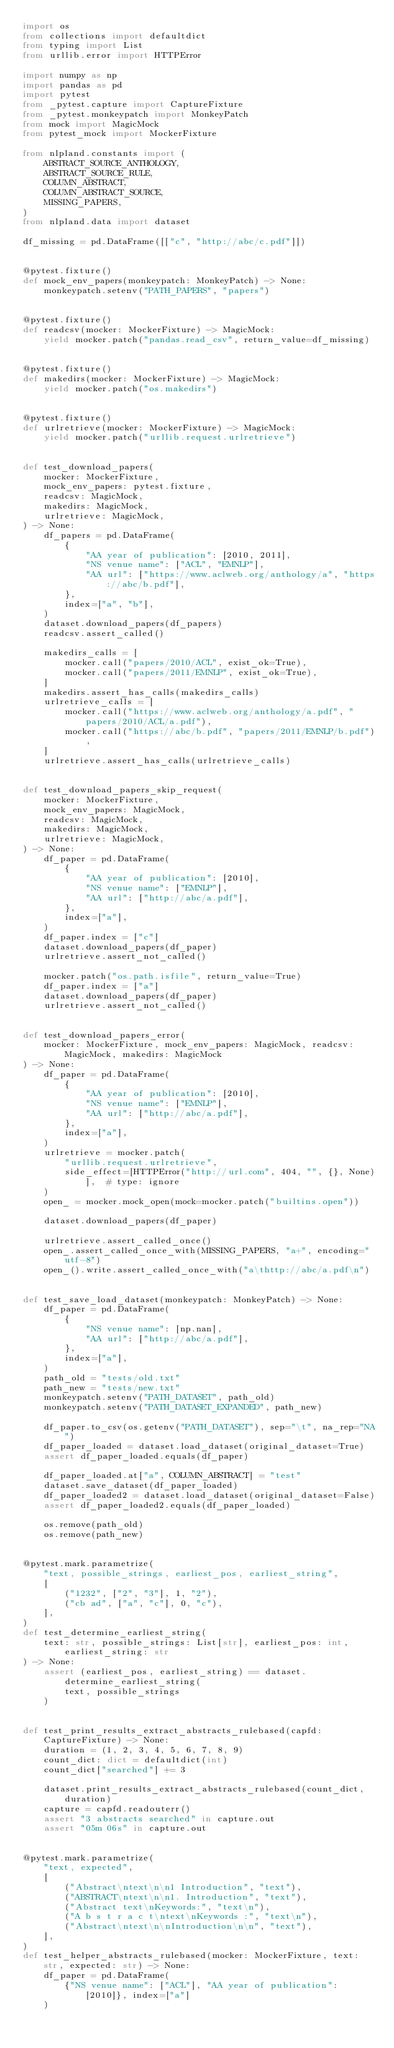Convert code to text. <code><loc_0><loc_0><loc_500><loc_500><_Python_>import os
from collections import defaultdict
from typing import List
from urllib.error import HTTPError

import numpy as np
import pandas as pd
import pytest
from _pytest.capture import CaptureFixture
from _pytest.monkeypatch import MonkeyPatch
from mock import MagicMock
from pytest_mock import MockerFixture

from nlpland.constants import (
    ABSTRACT_SOURCE_ANTHOLOGY,
    ABSTRACT_SOURCE_RULE,
    COLUMN_ABSTRACT,
    COLUMN_ABSTRACT_SOURCE,
    MISSING_PAPERS,
)
from nlpland.data import dataset

df_missing = pd.DataFrame([["c", "http://abc/c.pdf"]])


@pytest.fixture()
def mock_env_papers(monkeypatch: MonkeyPatch) -> None:
    monkeypatch.setenv("PATH_PAPERS", "papers")


@pytest.fixture()
def readcsv(mocker: MockerFixture) -> MagicMock:
    yield mocker.patch("pandas.read_csv", return_value=df_missing)


@pytest.fixture()
def makedirs(mocker: MockerFixture) -> MagicMock:
    yield mocker.patch("os.makedirs")


@pytest.fixture()
def urlretrieve(mocker: MockerFixture) -> MagicMock:
    yield mocker.patch("urllib.request.urlretrieve")


def test_download_papers(
    mocker: MockerFixture,
    mock_env_papers: pytest.fixture,
    readcsv: MagicMock,
    makedirs: MagicMock,
    urlretrieve: MagicMock,
) -> None:
    df_papers = pd.DataFrame(
        {
            "AA year of publication": [2010, 2011],
            "NS venue name": ["ACL", "EMNLP"],
            "AA url": ["https://www.aclweb.org/anthology/a", "https://abc/b.pdf"],
        },
        index=["a", "b"],
    )
    dataset.download_papers(df_papers)
    readcsv.assert_called()

    makedirs_calls = [
        mocker.call("papers/2010/ACL", exist_ok=True),
        mocker.call("papers/2011/EMNLP", exist_ok=True),
    ]
    makedirs.assert_has_calls(makedirs_calls)
    urlretrieve_calls = [
        mocker.call("https://www.aclweb.org/anthology/a.pdf", "papers/2010/ACL/a.pdf"),
        mocker.call("https://abc/b.pdf", "papers/2011/EMNLP/b.pdf"),
    ]
    urlretrieve.assert_has_calls(urlretrieve_calls)


def test_download_papers_skip_request(
    mocker: MockerFixture,
    mock_env_papers: MagicMock,
    readcsv: MagicMock,
    makedirs: MagicMock,
    urlretrieve: MagicMock,
) -> None:
    df_paper = pd.DataFrame(
        {
            "AA year of publication": [2010],
            "NS venue name": ["EMNLP"],
            "AA url": ["http://abc/a.pdf"],
        },
        index=["a"],
    )
    df_paper.index = ["c"]
    dataset.download_papers(df_paper)
    urlretrieve.assert_not_called()

    mocker.patch("os.path.isfile", return_value=True)
    df_paper.index = ["a"]
    dataset.download_papers(df_paper)
    urlretrieve.assert_not_called()


def test_download_papers_error(
    mocker: MockerFixture, mock_env_papers: MagicMock, readcsv: MagicMock, makedirs: MagicMock
) -> None:
    df_paper = pd.DataFrame(
        {
            "AA year of publication": [2010],
            "NS venue name": ["EMNLP"],
            "AA url": ["http://abc/a.pdf"],
        },
        index=["a"],
    )
    urlretrieve = mocker.patch(
        "urllib.request.urlretrieve",
        side_effect=[HTTPError("http://url.com", 404, "", {}, None)],  # type: ignore
    )
    open_ = mocker.mock_open(mock=mocker.patch("builtins.open"))

    dataset.download_papers(df_paper)

    urlretrieve.assert_called_once()
    open_.assert_called_once_with(MISSING_PAPERS, "a+", encoding="utf-8")
    open_().write.assert_called_once_with("a\thttp://abc/a.pdf\n")


def test_save_load_dataset(monkeypatch: MonkeyPatch) -> None:
    df_paper = pd.DataFrame(
        {
            "NS venue name": [np.nan],
            "AA url": ["http://abc/a.pdf"],
        },
        index=["a"],
    )
    path_old = "tests/old.txt"
    path_new = "tests/new.txt"
    monkeypatch.setenv("PATH_DATASET", path_old)
    monkeypatch.setenv("PATH_DATASET_EXPANDED", path_new)

    df_paper.to_csv(os.getenv("PATH_DATASET"), sep="\t", na_rep="NA")
    df_paper_loaded = dataset.load_dataset(original_dataset=True)
    assert df_paper_loaded.equals(df_paper)

    df_paper_loaded.at["a", COLUMN_ABSTRACT] = "test"
    dataset.save_dataset(df_paper_loaded)
    df_paper_loaded2 = dataset.load_dataset(original_dataset=False)
    assert df_paper_loaded2.equals(df_paper_loaded)

    os.remove(path_old)
    os.remove(path_new)


@pytest.mark.parametrize(
    "text, possible_strings, earliest_pos, earliest_string",
    [
        ("1232", ["2", "3"], 1, "2"),
        ("cb ad", ["a", "c"], 0, "c"),
    ],
)
def test_determine_earliest_string(
    text: str, possible_strings: List[str], earliest_pos: int, earliest_string: str
) -> None:
    assert (earliest_pos, earliest_string) == dataset.determine_earliest_string(
        text, possible_strings
    )


def test_print_results_extract_abstracts_rulebased(capfd: CaptureFixture) -> None:
    duration = (1, 2, 3, 4, 5, 6, 7, 8, 9)
    count_dict: dict = defaultdict(int)
    count_dict["searched"] += 3

    dataset.print_results_extract_abstracts_rulebased(count_dict, duration)
    capture = capfd.readouterr()
    assert "3 abstracts searched" in capture.out
    assert "05m 06s" in capture.out


@pytest.mark.parametrize(
    "text, expected",
    [
        ("Abstract\ntext\n\n1 Introduction", "text"),
        ("ABSTRACT\ntext\n\n1. Introduction", "text"),
        ("Abstract text\nKeywords:", "text\n"),
        ("A b s t r a c t\ntext\nKeywords :", "text\n"),
        ("Abstract\ntext\n\nIntroduction\n\n", "text"),
    ],
)
def test_helper_abstracts_rulebased(mocker: MockerFixture, text: str, expected: str) -> None:
    df_paper = pd.DataFrame(
        {"NS venue name": ["ACL"], "AA year of publication": [2010]}, index=["a"]
    )
</code> 